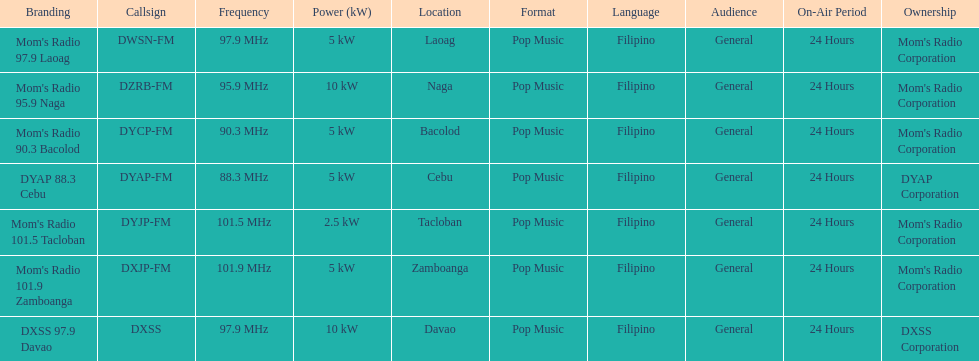What is the number of these stations broadcasting at a frequency of greater than 100 mhz? 2. 